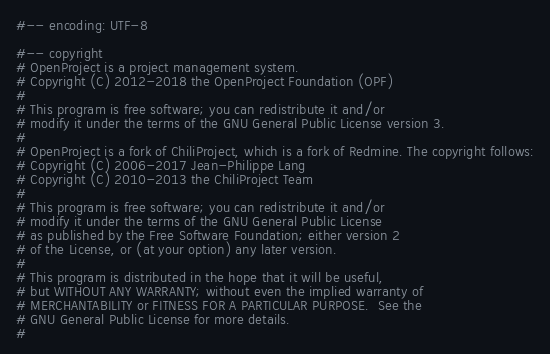Convert code to text. <code><loc_0><loc_0><loc_500><loc_500><_Ruby_>#-- encoding: UTF-8

#-- copyright
# OpenProject is a project management system.
# Copyright (C) 2012-2018 the OpenProject Foundation (OPF)
#
# This program is free software; you can redistribute it and/or
# modify it under the terms of the GNU General Public License version 3.
#
# OpenProject is a fork of ChiliProject, which is a fork of Redmine. The copyright follows:
# Copyright (C) 2006-2017 Jean-Philippe Lang
# Copyright (C) 2010-2013 the ChiliProject Team
#
# This program is free software; you can redistribute it and/or
# modify it under the terms of the GNU General Public License
# as published by the Free Software Foundation; either version 2
# of the License, or (at your option) any later version.
#
# This program is distributed in the hope that it will be useful,
# but WITHOUT ANY WARRANTY; without even the implied warranty of
# MERCHANTABILITY or FITNESS FOR A PARTICULAR PURPOSE.  See the
# GNU General Public License for more details.
#</code> 